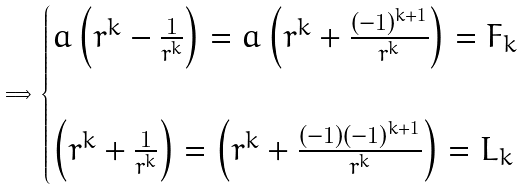<formula> <loc_0><loc_0><loc_500><loc_500>\implies \begin{cases} a \left ( r ^ { k } - \frac { 1 } { r ^ { k } } \right ) = a \left ( r ^ { k } + \frac { ( - 1 ) ^ { k + 1 } } { r ^ { k } } \right ) = F _ { k } \\ & \\ \left ( r ^ { k } + \frac { 1 } { r ^ { k } } \right ) = \left ( r ^ { k } + \frac { ( - 1 ) ( - 1 ) ^ { k + 1 } } { r ^ { k } } \right ) = L _ { k } \end{cases}</formula> 